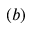Convert formula to latex. <formula><loc_0><loc_0><loc_500><loc_500>( b )</formula> 